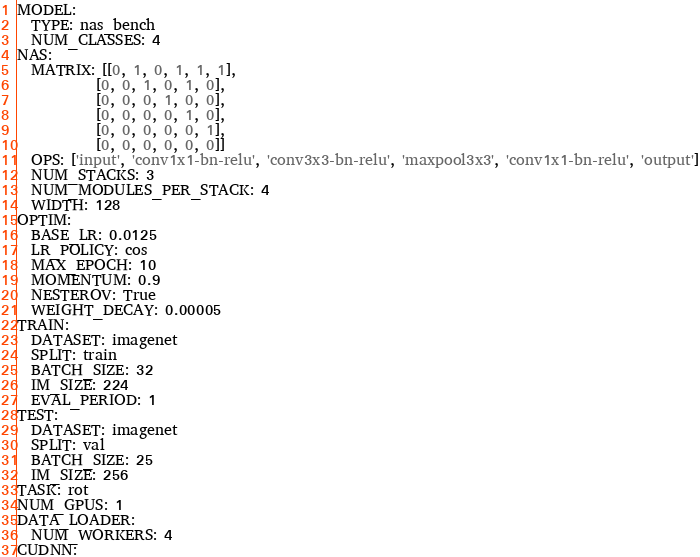<code> <loc_0><loc_0><loc_500><loc_500><_YAML_>MODEL:
  TYPE: nas_bench
  NUM_CLASSES: 4
NAS:
  MATRIX: [[0, 1, 0, 1, 1, 1],
           [0, 0, 1, 0, 1, 0],
           [0, 0, 0, 1, 0, 0],
           [0, 0, 0, 0, 1, 0],
           [0, 0, 0, 0, 0, 1],
           [0, 0, 0, 0, 0, 0]]
  OPS: ['input', 'conv1x1-bn-relu', 'conv3x3-bn-relu', 'maxpool3x3', 'conv1x1-bn-relu', 'output']
  NUM_STACKS: 3
  NUM_MODULES_PER_STACK: 4
  WIDTH: 128
OPTIM:
  BASE_LR: 0.0125
  LR_POLICY: cos
  MAX_EPOCH: 10
  MOMENTUM: 0.9
  NESTEROV: True
  WEIGHT_DECAY: 0.00005
TRAIN:
  DATASET: imagenet
  SPLIT: train
  BATCH_SIZE: 32
  IM_SIZE: 224
  EVAL_PERIOD: 1
TEST:
  DATASET: imagenet
  SPLIT: val
  BATCH_SIZE: 25
  IM_SIZE: 256
TASK: rot
NUM_GPUS: 1
DATA_LOADER:
  NUM_WORKERS: 4
CUDNN:</code> 